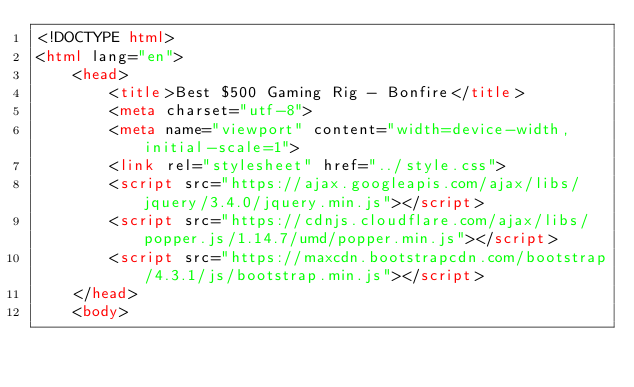<code> <loc_0><loc_0><loc_500><loc_500><_HTML_><!DOCTYPE html>
<html lang="en">
    <head>
        <title>Best $500 Gaming Rig - Bonfire</title>
        <meta charset="utf-8">
        <meta name="viewport" content="width=device-width, initial-scale=1">
        <link rel="stylesheet" href="../style.css">
        <script src="https://ajax.googleapis.com/ajax/libs/jquery/3.4.0/jquery.min.js"></script>
        <script src="https://cdnjs.cloudflare.com/ajax/libs/popper.js/1.14.7/umd/popper.min.js"></script>
        <script src="https://maxcdn.bootstrapcdn.com/bootstrap/4.3.1/js/bootstrap.min.js"></script>
    </head>
    <body></code> 